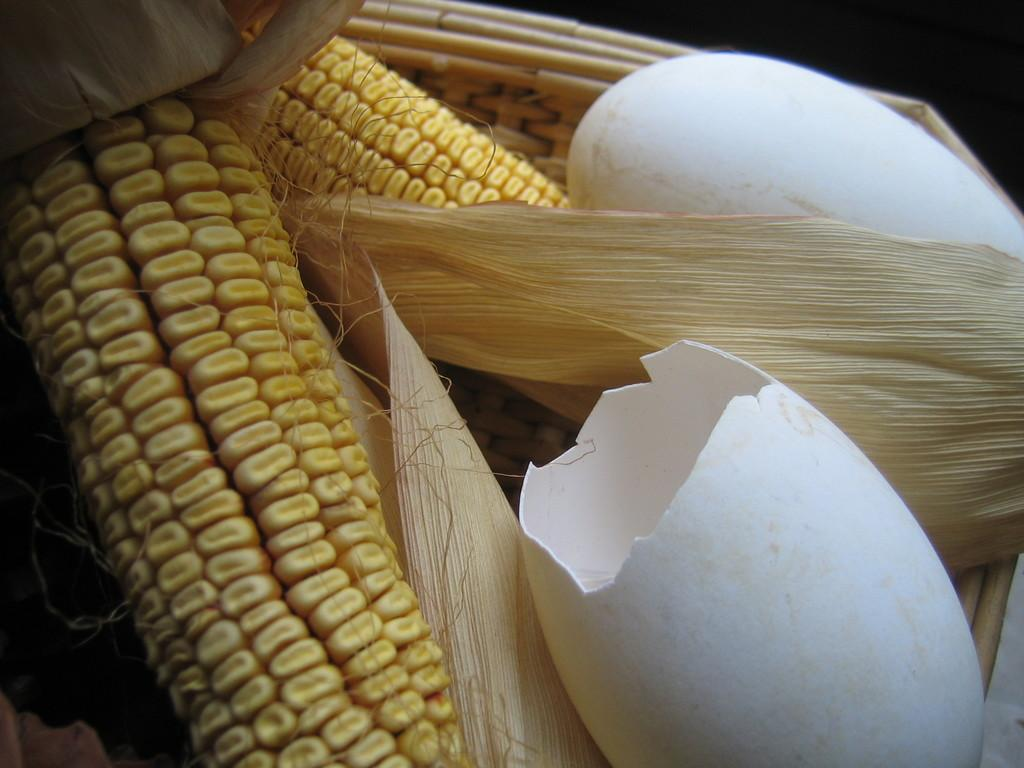What type of food is present in the image? There is maize in the image. What other item can be seen in the image? There are egg shells in the image. Where are the maize and egg shells located? The maize and egg shells are in a basket. How many rabbits are sitting on the van in the image? There are no rabbits or vans present in the image. What type of flag is visible in the image? There is no flag present in the image. 